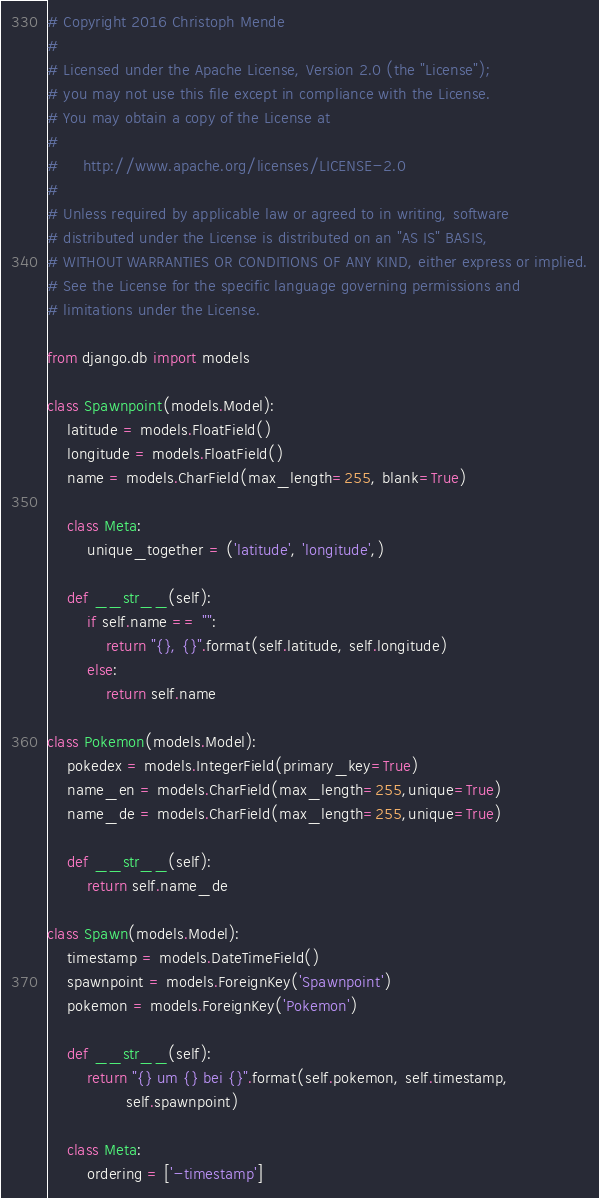<code> <loc_0><loc_0><loc_500><loc_500><_Python_># Copyright 2016 Christoph Mende 
#
# Licensed under the Apache License, Version 2.0 (the "License");
# you may not use this file except in compliance with the License.
# You may obtain a copy of the License at
#
#     http://www.apache.org/licenses/LICENSE-2.0
#
# Unless required by applicable law or agreed to in writing, software
# distributed under the License is distributed on an "AS IS" BASIS,
# WITHOUT WARRANTIES OR CONDITIONS OF ANY KIND, either express or implied.
# See the License for the specific language governing permissions and
# limitations under the License.

from django.db import models

class Spawnpoint(models.Model):
    latitude = models.FloatField()
    longitude = models.FloatField()
    name = models.CharField(max_length=255, blank=True)

    class Meta:
        unique_together = ('latitude', 'longitude',)

    def __str__(self):
        if self.name == "":
            return "{}, {}".format(self.latitude, self.longitude)
        else:
            return self.name

class Pokemon(models.Model):
    pokedex = models.IntegerField(primary_key=True)
    name_en = models.CharField(max_length=255,unique=True)
    name_de = models.CharField(max_length=255,unique=True)

    def __str__(self):
        return self.name_de

class Spawn(models.Model):
    timestamp = models.DateTimeField()
    spawnpoint = models.ForeignKey('Spawnpoint')
    pokemon = models.ForeignKey('Pokemon')

    def __str__(self):
        return "{} um {} bei {}".format(self.pokemon, self.timestamp,
                self.spawnpoint)

    class Meta:
        ordering = ['-timestamp']
</code> 